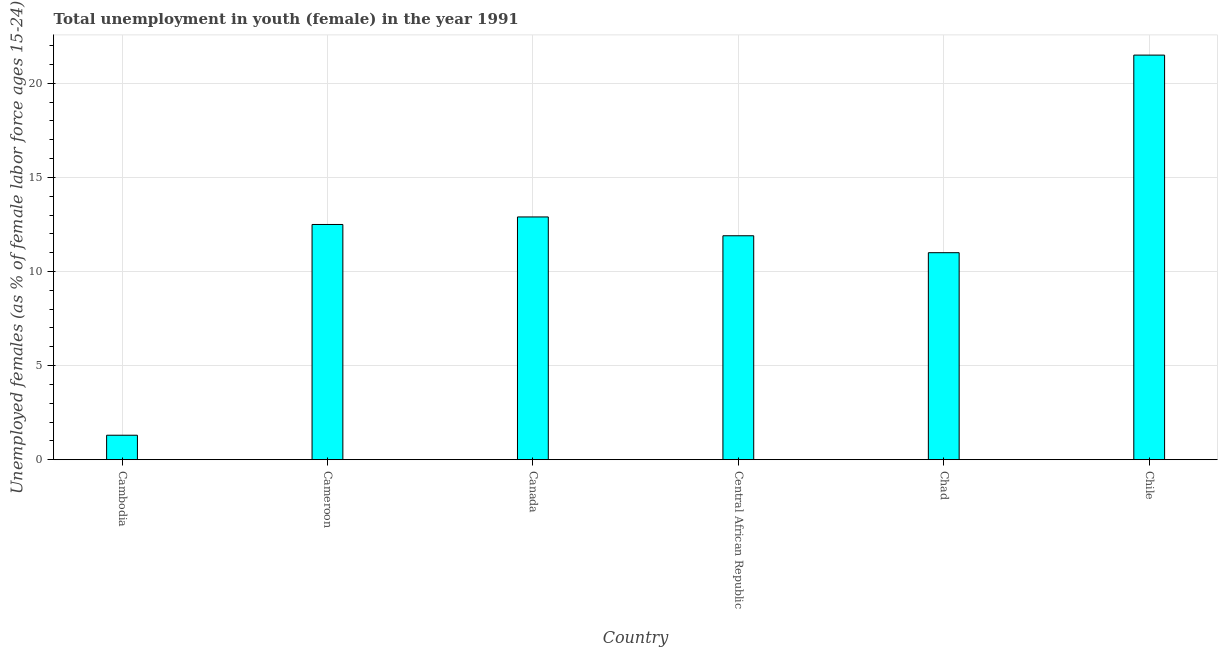Does the graph contain grids?
Keep it short and to the point. Yes. What is the title of the graph?
Your answer should be very brief. Total unemployment in youth (female) in the year 1991. What is the label or title of the X-axis?
Offer a very short reply. Country. What is the label or title of the Y-axis?
Offer a very short reply. Unemployed females (as % of female labor force ages 15-24). What is the unemployed female youth population in Central African Republic?
Ensure brevity in your answer.  11.9. Across all countries, what is the maximum unemployed female youth population?
Your answer should be compact. 21.5. Across all countries, what is the minimum unemployed female youth population?
Make the answer very short. 1.3. In which country was the unemployed female youth population maximum?
Provide a short and direct response. Chile. In which country was the unemployed female youth population minimum?
Your response must be concise. Cambodia. What is the sum of the unemployed female youth population?
Make the answer very short. 71.1. What is the average unemployed female youth population per country?
Give a very brief answer. 11.85. What is the median unemployed female youth population?
Offer a very short reply. 12.2. What is the ratio of the unemployed female youth population in Central African Republic to that in Chile?
Offer a terse response. 0.55. What is the difference between the highest and the second highest unemployed female youth population?
Provide a short and direct response. 8.6. Is the sum of the unemployed female youth population in Cambodia and Chad greater than the maximum unemployed female youth population across all countries?
Provide a short and direct response. No. What is the difference between the highest and the lowest unemployed female youth population?
Provide a short and direct response. 20.2. In how many countries, is the unemployed female youth population greater than the average unemployed female youth population taken over all countries?
Offer a terse response. 4. What is the difference between two consecutive major ticks on the Y-axis?
Give a very brief answer. 5. What is the Unemployed females (as % of female labor force ages 15-24) in Cambodia?
Your answer should be very brief. 1.3. What is the Unemployed females (as % of female labor force ages 15-24) in Cameroon?
Make the answer very short. 12.5. What is the Unemployed females (as % of female labor force ages 15-24) of Canada?
Make the answer very short. 12.9. What is the Unemployed females (as % of female labor force ages 15-24) of Central African Republic?
Your answer should be very brief. 11.9. What is the Unemployed females (as % of female labor force ages 15-24) of Chad?
Give a very brief answer. 11. What is the difference between the Unemployed females (as % of female labor force ages 15-24) in Cambodia and Cameroon?
Keep it short and to the point. -11.2. What is the difference between the Unemployed females (as % of female labor force ages 15-24) in Cambodia and Central African Republic?
Your response must be concise. -10.6. What is the difference between the Unemployed females (as % of female labor force ages 15-24) in Cambodia and Chad?
Offer a very short reply. -9.7. What is the difference between the Unemployed females (as % of female labor force ages 15-24) in Cambodia and Chile?
Offer a terse response. -20.2. What is the difference between the Unemployed females (as % of female labor force ages 15-24) in Cameroon and Canada?
Ensure brevity in your answer.  -0.4. What is the difference between the Unemployed females (as % of female labor force ages 15-24) in Cameroon and Central African Republic?
Offer a very short reply. 0.6. What is the difference between the Unemployed females (as % of female labor force ages 15-24) in Cameroon and Chile?
Offer a very short reply. -9. What is the difference between the Unemployed females (as % of female labor force ages 15-24) in Canada and Chile?
Your answer should be very brief. -8.6. What is the difference between the Unemployed females (as % of female labor force ages 15-24) in Central African Republic and Chad?
Ensure brevity in your answer.  0.9. What is the difference between the Unemployed females (as % of female labor force ages 15-24) in Central African Republic and Chile?
Your answer should be compact. -9.6. What is the ratio of the Unemployed females (as % of female labor force ages 15-24) in Cambodia to that in Cameroon?
Provide a succinct answer. 0.1. What is the ratio of the Unemployed females (as % of female labor force ages 15-24) in Cambodia to that in Canada?
Ensure brevity in your answer.  0.1. What is the ratio of the Unemployed females (as % of female labor force ages 15-24) in Cambodia to that in Central African Republic?
Make the answer very short. 0.11. What is the ratio of the Unemployed females (as % of female labor force ages 15-24) in Cambodia to that in Chad?
Your answer should be compact. 0.12. What is the ratio of the Unemployed females (as % of female labor force ages 15-24) in Cambodia to that in Chile?
Offer a very short reply. 0.06. What is the ratio of the Unemployed females (as % of female labor force ages 15-24) in Cameroon to that in Central African Republic?
Your response must be concise. 1.05. What is the ratio of the Unemployed females (as % of female labor force ages 15-24) in Cameroon to that in Chad?
Your response must be concise. 1.14. What is the ratio of the Unemployed females (as % of female labor force ages 15-24) in Cameroon to that in Chile?
Provide a succinct answer. 0.58. What is the ratio of the Unemployed females (as % of female labor force ages 15-24) in Canada to that in Central African Republic?
Your answer should be very brief. 1.08. What is the ratio of the Unemployed females (as % of female labor force ages 15-24) in Canada to that in Chad?
Offer a terse response. 1.17. What is the ratio of the Unemployed females (as % of female labor force ages 15-24) in Canada to that in Chile?
Your response must be concise. 0.6. What is the ratio of the Unemployed females (as % of female labor force ages 15-24) in Central African Republic to that in Chad?
Give a very brief answer. 1.08. What is the ratio of the Unemployed females (as % of female labor force ages 15-24) in Central African Republic to that in Chile?
Your answer should be compact. 0.55. What is the ratio of the Unemployed females (as % of female labor force ages 15-24) in Chad to that in Chile?
Provide a short and direct response. 0.51. 